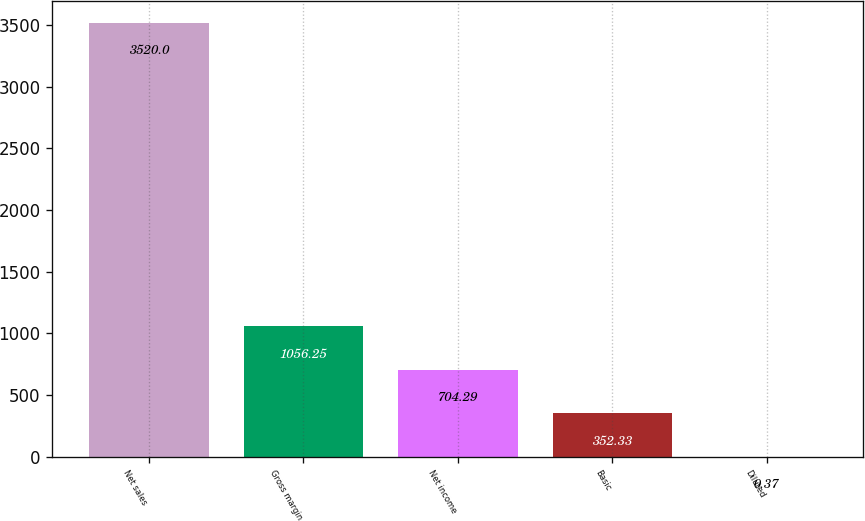<chart> <loc_0><loc_0><loc_500><loc_500><bar_chart><fcel>Net sales<fcel>Gross margin<fcel>Net income<fcel>Basic<fcel>Diluted<nl><fcel>3520<fcel>1056.25<fcel>704.29<fcel>352.33<fcel>0.37<nl></chart> 